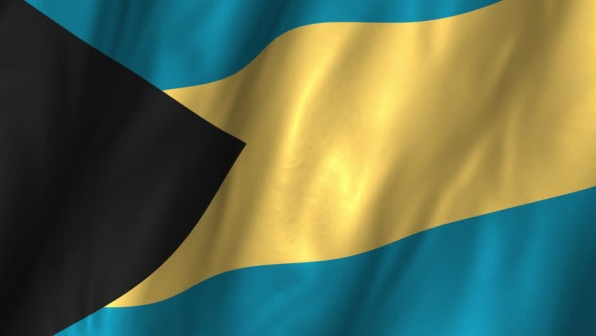In what realistic ways could the flag be incorporated into an educational program for schools in the Bahamas? In an educational program for Bahamian schools, the flag could be used to instill pride and teach students about their national identity and heritage. Lessons could include the history and symbolism of the flag, explaining what each color and shape represents. Students could engage in activities like creating their own versions of the flag using different media and presenting what their designs symbolize about their local environment and community values. Additionally, field trips to historical sites and museums could be organized to provide context and deeper understanding. Flag-related projects could also be integrated into subjects such as art, history, and social studies, fostering a comprehensive appreciation of the nation’s culture and achievements. 